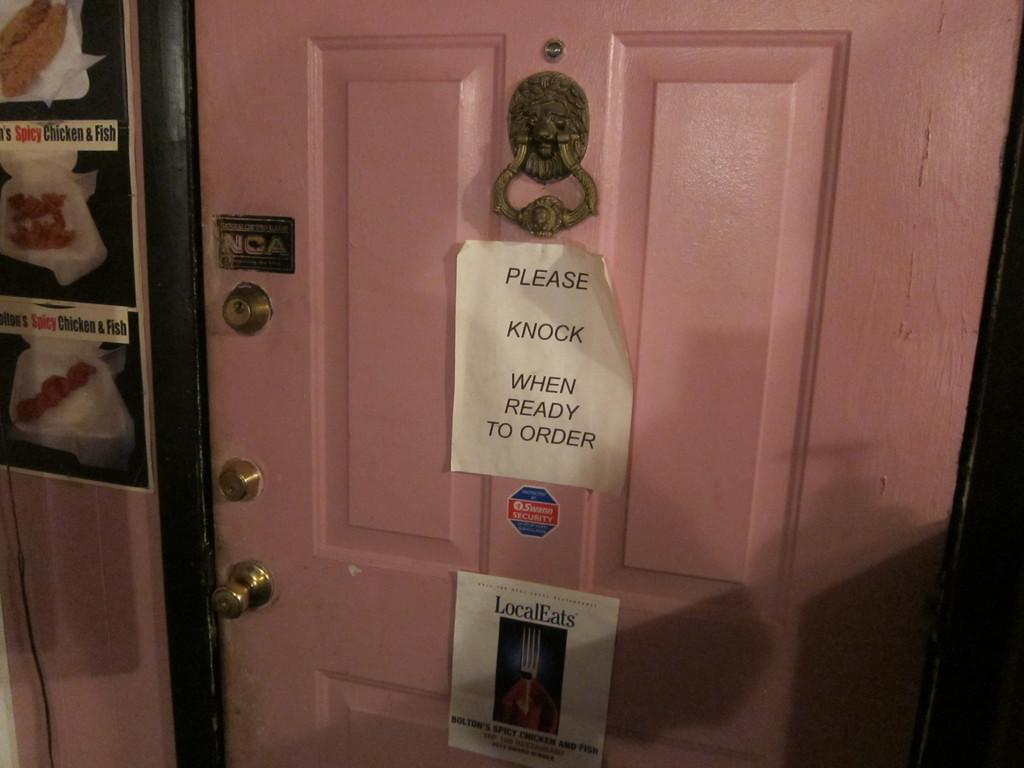<image>
Relay a brief, clear account of the picture shown. A pink door has a white sheet of paper reading Please Knock When Ready To Order below the door knocker. 